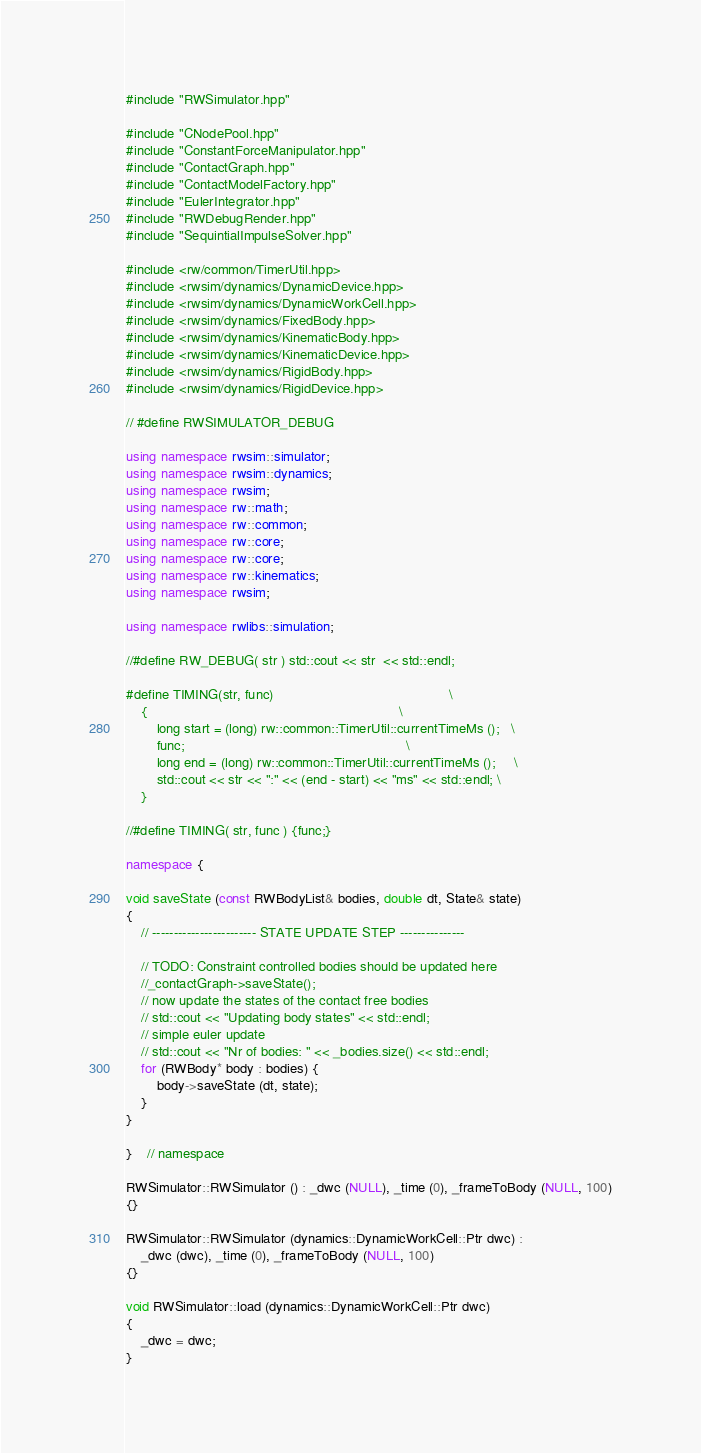Convert code to text. <code><loc_0><loc_0><loc_500><loc_500><_C++_>#include "RWSimulator.hpp"

#include "CNodePool.hpp"
#include "ConstantForceManipulator.hpp"
#include "ContactGraph.hpp"
#include "ContactModelFactory.hpp"
#include "EulerIntegrator.hpp"
#include "RWDebugRender.hpp"
#include "SequintialImpulseSolver.hpp"

#include <rw/common/TimerUtil.hpp>
#include <rwsim/dynamics/DynamicDevice.hpp>
#include <rwsim/dynamics/DynamicWorkCell.hpp>
#include <rwsim/dynamics/FixedBody.hpp>
#include <rwsim/dynamics/KinematicBody.hpp>
#include <rwsim/dynamics/KinematicDevice.hpp>
#include <rwsim/dynamics/RigidBody.hpp>
#include <rwsim/dynamics/RigidDevice.hpp>

// #define RWSIMULATOR_DEBUG

using namespace rwsim::simulator;
using namespace rwsim::dynamics;
using namespace rwsim;
using namespace rw::math;
using namespace rw::common;
using namespace rw::core;
using namespace rw::core;
using namespace rw::kinematics;
using namespace rwsim;

using namespace rwlibs::simulation;

//#define RW_DEBUG( str ) std::cout << str  << std::endl;

#define TIMING(str, func)                                              \
    {                                                                  \
        long start = (long) rw::common::TimerUtil::currentTimeMs ();   \
        func;                                                          \
        long end = (long) rw::common::TimerUtil::currentTimeMs ();     \
        std::cout << str << ":" << (end - start) << "ms" << std::endl; \
    }

//#define TIMING( str, func ) {func;}

namespace {

void saveState (const RWBodyList& bodies, double dt, State& state)
{
    // ------------------------ STATE UPDATE STEP ---------------

    // TODO: Constraint controlled bodies should be updated here
    //_contactGraph->saveState();
    // now update the states of the contact free bodies
    // std::cout << "Updating body states" << std::endl;
    // simple euler update
    // std::cout << "Nr of bodies: " << _bodies.size() << std::endl;
    for (RWBody* body : bodies) {
        body->saveState (dt, state);
    }
}

}    // namespace

RWSimulator::RWSimulator () : _dwc (NULL), _time (0), _frameToBody (NULL, 100)
{}

RWSimulator::RWSimulator (dynamics::DynamicWorkCell::Ptr dwc) :
    _dwc (dwc), _time (0), _frameToBody (NULL, 100)
{}

void RWSimulator::load (dynamics::DynamicWorkCell::Ptr dwc)
{
    _dwc = dwc;
}
</code> 